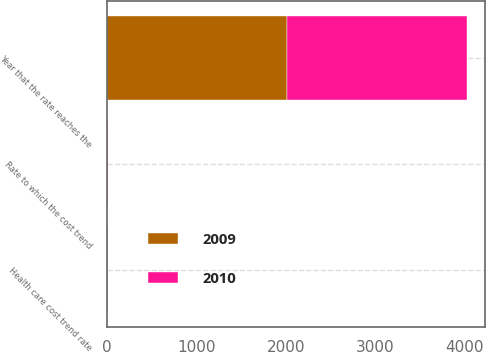Convert chart to OTSL. <chart><loc_0><loc_0><loc_500><loc_500><stacked_bar_chart><ecel><fcel>Health care cost trend rate<fcel>Rate to which the cost trend<fcel>Year that the rate reaches the<nl><fcel>2010<fcel>10<fcel>5<fcel>2015<nl><fcel>2009<fcel>10<fcel>5<fcel>2015<nl></chart> 